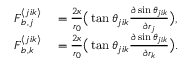Convert formula to latex. <formula><loc_0><loc_0><loc_500><loc_500>\begin{array} { r l } { F _ { b , j } ^ { \langle j i k \rangle } } & = \frac { 2 \kappa } { r _ { 0 } } \left ( \tan \theta _ { j i k } \frac { \partial \sin \theta _ { j i k } } { \partial r _ { j } } \right ) , } \\ { F _ { b , k } ^ { \langle j i k \rangle } } & = \frac { 2 \kappa } { r _ { 0 } } \left ( \tan \theta _ { j i k } \frac { \partial \sin \theta _ { j i k } } { \partial r _ { k } } \right ) . } \end{array}</formula> 